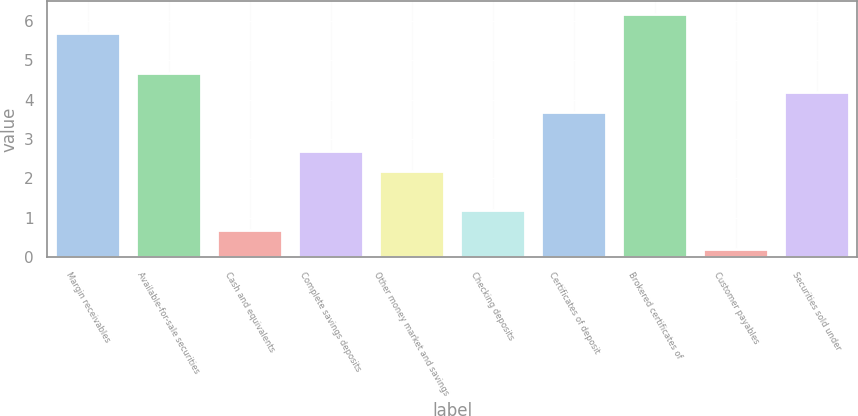<chart> <loc_0><loc_0><loc_500><loc_500><bar_chart><fcel>Margin receivables<fcel>Available-for-sale securities<fcel>Cash and equivalents<fcel>Complete savings deposits<fcel>Other money market and savings<fcel>Checking deposits<fcel>Certificates of deposit<fcel>Brokered certificates of<fcel>Customer payables<fcel>Securities sold under<nl><fcel>5.69<fcel>4.69<fcel>0.69<fcel>2.69<fcel>2.19<fcel>1.19<fcel>3.69<fcel>6.19<fcel>0.19<fcel>4.19<nl></chart> 